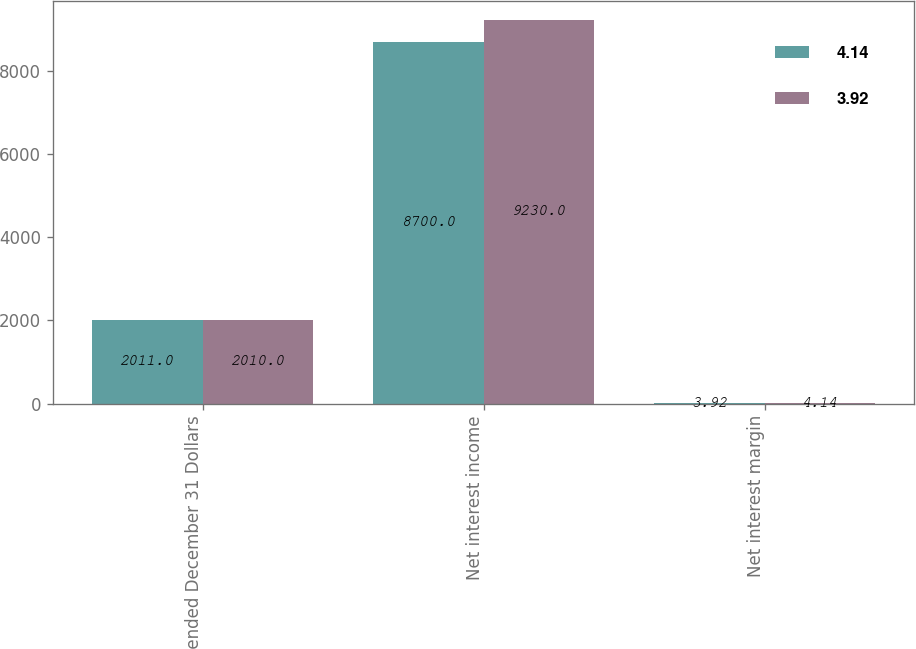Convert chart to OTSL. <chart><loc_0><loc_0><loc_500><loc_500><stacked_bar_chart><ecel><fcel>Year ended December 31 Dollars<fcel>Net interest income<fcel>Net interest margin<nl><fcel>4.14<fcel>2011<fcel>8700<fcel>3.92<nl><fcel>3.92<fcel>2010<fcel>9230<fcel>4.14<nl></chart> 